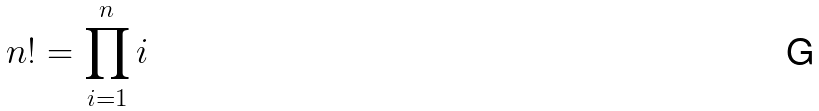Convert formula to latex. <formula><loc_0><loc_0><loc_500><loc_500>n ! = \prod _ { i = 1 } ^ { n } i</formula> 